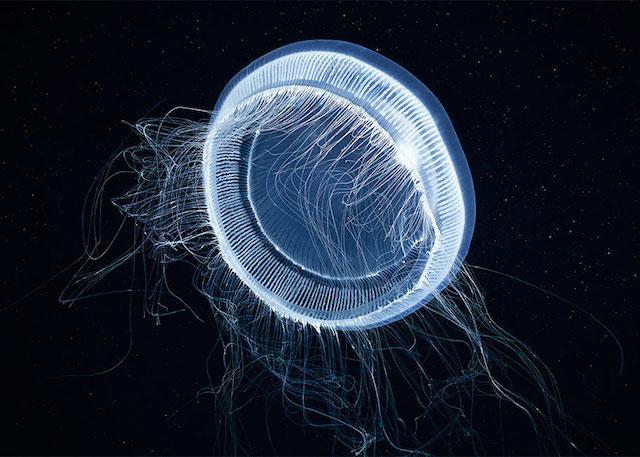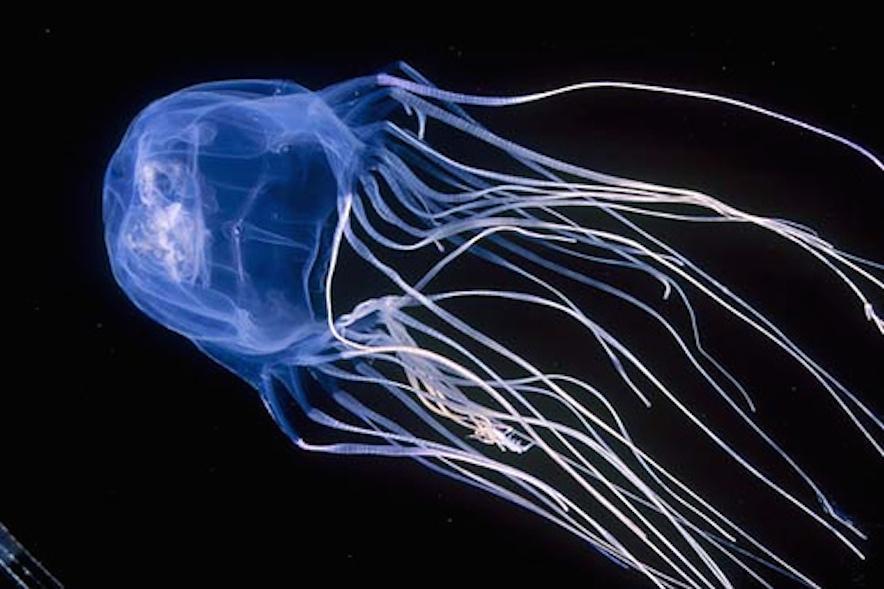The first image is the image on the left, the second image is the image on the right. For the images displayed, is the sentence "In at least one image there is on blue lit jellyfish whose head cap is straight up and down." factually correct? Answer yes or no. No. 